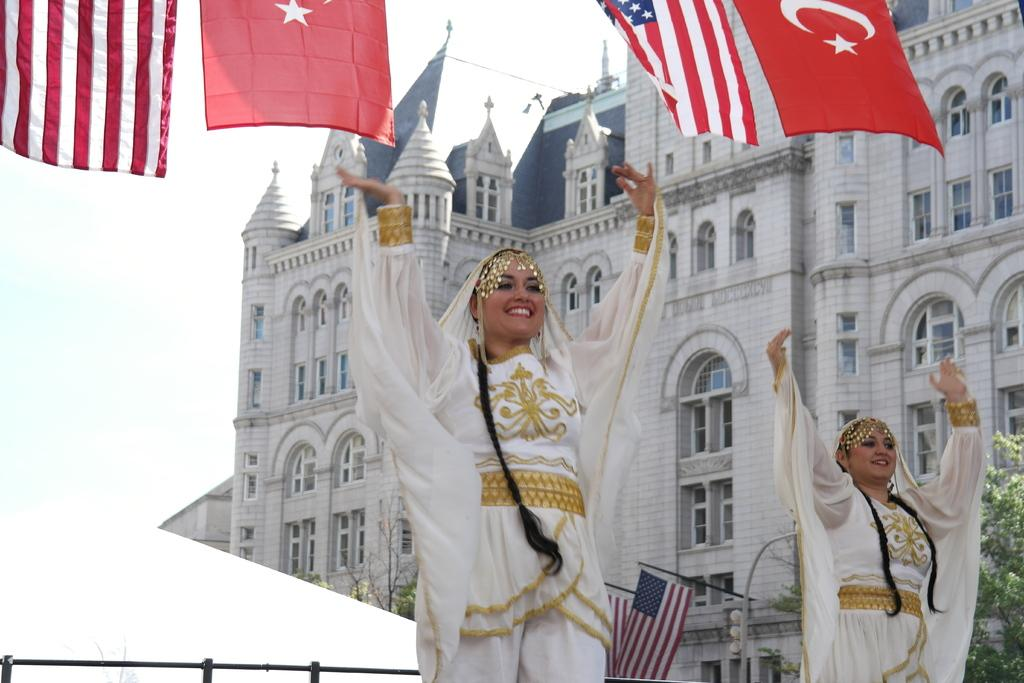How many women are in the image? There are two women in the image. What are the women doing in the image? The women are dancing. What are the women wearing in the image? The women are wearing white dresses. How many flags are in the image? There are four flags in the image. What do the flags represent in the image? The flags represent two countries. What can be seen in the background of the image? There is a big building in the background of the image. What type of crow can be seen flying over the building in the image? There is no crow present in the image; it only features two women dancing, four flags, and a big building in the background. What kind of insect is crawling on the women's dresses in the image? There are no insects visible on the women's dresses in the image. 